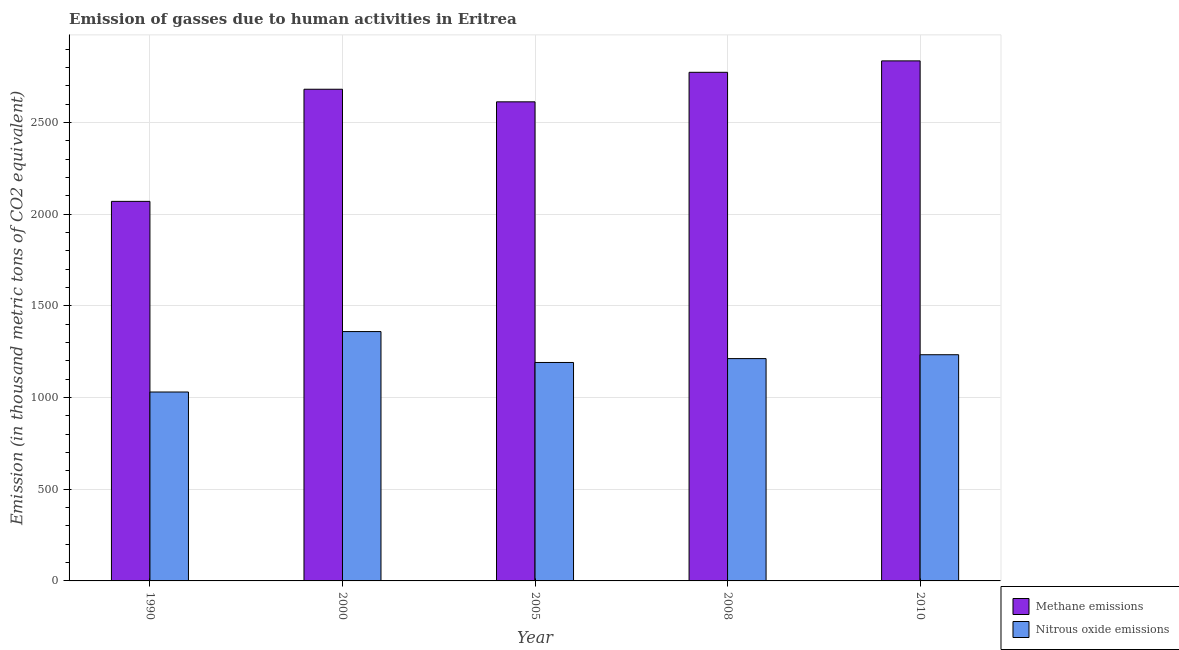How many different coloured bars are there?
Provide a short and direct response. 2. How many groups of bars are there?
Give a very brief answer. 5. How many bars are there on the 5th tick from the left?
Provide a short and direct response. 2. What is the label of the 2nd group of bars from the left?
Your response must be concise. 2000. In how many cases, is the number of bars for a given year not equal to the number of legend labels?
Give a very brief answer. 0. What is the amount of nitrous oxide emissions in 2005?
Ensure brevity in your answer.  1191.7. Across all years, what is the maximum amount of nitrous oxide emissions?
Provide a succinct answer. 1360.3. Across all years, what is the minimum amount of methane emissions?
Make the answer very short. 2070.6. In which year was the amount of methane emissions maximum?
Ensure brevity in your answer.  2010. In which year was the amount of nitrous oxide emissions minimum?
Your answer should be very brief. 1990. What is the total amount of methane emissions in the graph?
Give a very brief answer. 1.30e+04. What is the difference between the amount of methane emissions in 2005 and that in 2010?
Keep it short and to the point. -223.4. What is the difference between the amount of methane emissions in 2008 and the amount of nitrous oxide emissions in 2010?
Your answer should be compact. -62.3. What is the average amount of nitrous oxide emissions per year?
Offer a terse response. 1205.88. In the year 1990, what is the difference between the amount of nitrous oxide emissions and amount of methane emissions?
Provide a short and direct response. 0. In how many years, is the amount of nitrous oxide emissions greater than 1900 thousand metric tons?
Your answer should be compact. 0. What is the ratio of the amount of methane emissions in 1990 to that in 2000?
Give a very brief answer. 0.77. What is the difference between the highest and the second highest amount of methane emissions?
Make the answer very short. 62.3. What is the difference between the highest and the lowest amount of nitrous oxide emissions?
Keep it short and to the point. 329.7. What does the 1st bar from the left in 2000 represents?
Your answer should be very brief. Methane emissions. What does the 1st bar from the right in 2008 represents?
Your answer should be compact. Nitrous oxide emissions. Are all the bars in the graph horizontal?
Make the answer very short. No. What is the difference between two consecutive major ticks on the Y-axis?
Provide a succinct answer. 500. How are the legend labels stacked?
Offer a very short reply. Vertical. What is the title of the graph?
Your response must be concise. Emission of gasses due to human activities in Eritrea. Does "Rural Population" appear as one of the legend labels in the graph?
Ensure brevity in your answer.  No. What is the label or title of the Y-axis?
Provide a short and direct response. Emission (in thousand metric tons of CO2 equivalent). What is the Emission (in thousand metric tons of CO2 equivalent) in Methane emissions in 1990?
Your answer should be very brief. 2070.6. What is the Emission (in thousand metric tons of CO2 equivalent) of Nitrous oxide emissions in 1990?
Your response must be concise. 1030.6. What is the Emission (in thousand metric tons of CO2 equivalent) in Methane emissions in 2000?
Offer a very short reply. 2682.3. What is the Emission (in thousand metric tons of CO2 equivalent) of Nitrous oxide emissions in 2000?
Your response must be concise. 1360.3. What is the Emission (in thousand metric tons of CO2 equivalent) of Methane emissions in 2005?
Your response must be concise. 2613.6. What is the Emission (in thousand metric tons of CO2 equivalent) in Nitrous oxide emissions in 2005?
Offer a very short reply. 1191.7. What is the Emission (in thousand metric tons of CO2 equivalent) in Methane emissions in 2008?
Your answer should be compact. 2774.7. What is the Emission (in thousand metric tons of CO2 equivalent) of Nitrous oxide emissions in 2008?
Ensure brevity in your answer.  1212.8. What is the Emission (in thousand metric tons of CO2 equivalent) in Methane emissions in 2010?
Your answer should be very brief. 2837. What is the Emission (in thousand metric tons of CO2 equivalent) in Nitrous oxide emissions in 2010?
Provide a short and direct response. 1234. Across all years, what is the maximum Emission (in thousand metric tons of CO2 equivalent) in Methane emissions?
Your answer should be compact. 2837. Across all years, what is the maximum Emission (in thousand metric tons of CO2 equivalent) of Nitrous oxide emissions?
Give a very brief answer. 1360.3. Across all years, what is the minimum Emission (in thousand metric tons of CO2 equivalent) in Methane emissions?
Give a very brief answer. 2070.6. Across all years, what is the minimum Emission (in thousand metric tons of CO2 equivalent) in Nitrous oxide emissions?
Offer a very short reply. 1030.6. What is the total Emission (in thousand metric tons of CO2 equivalent) in Methane emissions in the graph?
Your answer should be very brief. 1.30e+04. What is the total Emission (in thousand metric tons of CO2 equivalent) of Nitrous oxide emissions in the graph?
Offer a terse response. 6029.4. What is the difference between the Emission (in thousand metric tons of CO2 equivalent) of Methane emissions in 1990 and that in 2000?
Your answer should be very brief. -611.7. What is the difference between the Emission (in thousand metric tons of CO2 equivalent) of Nitrous oxide emissions in 1990 and that in 2000?
Provide a succinct answer. -329.7. What is the difference between the Emission (in thousand metric tons of CO2 equivalent) in Methane emissions in 1990 and that in 2005?
Your answer should be compact. -543. What is the difference between the Emission (in thousand metric tons of CO2 equivalent) in Nitrous oxide emissions in 1990 and that in 2005?
Provide a short and direct response. -161.1. What is the difference between the Emission (in thousand metric tons of CO2 equivalent) of Methane emissions in 1990 and that in 2008?
Your response must be concise. -704.1. What is the difference between the Emission (in thousand metric tons of CO2 equivalent) in Nitrous oxide emissions in 1990 and that in 2008?
Make the answer very short. -182.2. What is the difference between the Emission (in thousand metric tons of CO2 equivalent) in Methane emissions in 1990 and that in 2010?
Keep it short and to the point. -766.4. What is the difference between the Emission (in thousand metric tons of CO2 equivalent) in Nitrous oxide emissions in 1990 and that in 2010?
Keep it short and to the point. -203.4. What is the difference between the Emission (in thousand metric tons of CO2 equivalent) in Methane emissions in 2000 and that in 2005?
Offer a very short reply. 68.7. What is the difference between the Emission (in thousand metric tons of CO2 equivalent) in Nitrous oxide emissions in 2000 and that in 2005?
Your response must be concise. 168.6. What is the difference between the Emission (in thousand metric tons of CO2 equivalent) in Methane emissions in 2000 and that in 2008?
Give a very brief answer. -92.4. What is the difference between the Emission (in thousand metric tons of CO2 equivalent) in Nitrous oxide emissions in 2000 and that in 2008?
Offer a terse response. 147.5. What is the difference between the Emission (in thousand metric tons of CO2 equivalent) of Methane emissions in 2000 and that in 2010?
Make the answer very short. -154.7. What is the difference between the Emission (in thousand metric tons of CO2 equivalent) of Nitrous oxide emissions in 2000 and that in 2010?
Your response must be concise. 126.3. What is the difference between the Emission (in thousand metric tons of CO2 equivalent) of Methane emissions in 2005 and that in 2008?
Ensure brevity in your answer.  -161.1. What is the difference between the Emission (in thousand metric tons of CO2 equivalent) of Nitrous oxide emissions in 2005 and that in 2008?
Give a very brief answer. -21.1. What is the difference between the Emission (in thousand metric tons of CO2 equivalent) in Methane emissions in 2005 and that in 2010?
Your response must be concise. -223.4. What is the difference between the Emission (in thousand metric tons of CO2 equivalent) of Nitrous oxide emissions in 2005 and that in 2010?
Keep it short and to the point. -42.3. What is the difference between the Emission (in thousand metric tons of CO2 equivalent) in Methane emissions in 2008 and that in 2010?
Give a very brief answer. -62.3. What is the difference between the Emission (in thousand metric tons of CO2 equivalent) of Nitrous oxide emissions in 2008 and that in 2010?
Ensure brevity in your answer.  -21.2. What is the difference between the Emission (in thousand metric tons of CO2 equivalent) of Methane emissions in 1990 and the Emission (in thousand metric tons of CO2 equivalent) of Nitrous oxide emissions in 2000?
Make the answer very short. 710.3. What is the difference between the Emission (in thousand metric tons of CO2 equivalent) of Methane emissions in 1990 and the Emission (in thousand metric tons of CO2 equivalent) of Nitrous oxide emissions in 2005?
Give a very brief answer. 878.9. What is the difference between the Emission (in thousand metric tons of CO2 equivalent) in Methane emissions in 1990 and the Emission (in thousand metric tons of CO2 equivalent) in Nitrous oxide emissions in 2008?
Ensure brevity in your answer.  857.8. What is the difference between the Emission (in thousand metric tons of CO2 equivalent) of Methane emissions in 1990 and the Emission (in thousand metric tons of CO2 equivalent) of Nitrous oxide emissions in 2010?
Your response must be concise. 836.6. What is the difference between the Emission (in thousand metric tons of CO2 equivalent) of Methane emissions in 2000 and the Emission (in thousand metric tons of CO2 equivalent) of Nitrous oxide emissions in 2005?
Your response must be concise. 1490.6. What is the difference between the Emission (in thousand metric tons of CO2 equivalent) in Methane emissions in 2000 and the Emission (in thousand metric tons of CO2 equivalent) in Nitrous oxide emissions in 2008?
Provide a short and direct response. 1469.5. What is the difference between the Emission (in thousand metric tons of CO2 equivalent) in Methane emissions in 2000 and the Emission (in thousand metric tons of CO2 equivalent) in Nitrous oxide emissions in 2010?
Give a very brief answer. 1448.3. What is the difference between the Emission (in thousand metric tons of CO2 equivalent) of Methane emissions in 2005 and the Emission (in thousand metric tons of CO2 equivalent) of Nitrous oxide emissions in 2008?
Your response must be concise. 1400.8. What is the difference between the Emission (in thousand metric tons of CO2 equivalent) of Methane emissions in 2005 and the Emission (in thousand metric tons of CO2 equivalent) of Nitrous oxide emissions in 2010?
Provide a short and direct response. 1379.6. What is the difference between the Emission (in thousand metric tons of CO2 equivalent) in Methane emissions in 2008 and the Emission (in thousand metric tons of CO2 equivalent) in Nitrous oxide emissions in 2010?
Your answer should be compact. 1540.7. What is the average Emission (in thousand metric tons of CO2 equivalent) in Methane emissions per year?
Your answer should be compact. 2595.64. What is the average Emission (in thousand metric tons of CO2 equivalent) of Nitrous oxide emissions per year?
Ensure brevity in your answer.  1205.88. In the year 1990, what is the difference between the Emission (in thousand metric tons of CO2 equivalent) of Methane emissions and Emission (in thousand metric tons of CO2 equivalent) of Nitrous oxide emissions?
Your answer should be very brief. 1040. In the year 2000, what is the difference between the Emission (in thousand metric tons of CO2 equivalent) in Methane emissions and Emission (in thousand metric tons of CO2 equivalent) in Nitrous oxide emissions?
Your answer should be compact. 1322. In the year 2005, what is the difference between the Emission (in thousand metric tons of CO2 equivalent) of Methane emissions and Emission (in thousand metric tons of CO2 equivalent) of Nitrous oxide emissions?
Provide a succinct answer. 1421.9. In the year 2008, what is the difference between the Emission (in thousand metric tons of CO2 equivalent) in Methane emissions and Emission (in thousand metric tons of CO2 equivalent) in Nitrous oxide emissions?
Give a very brief answer. 1561.9. In the year 2010, what is the difference between the Emission (in thousand metric tons of CO2 equivalent) of Methane emissions and Emission (in thousand metric tons of CO2 equivalent) of Nitrous oxide emissions?
Make the answer very short. 1603. What is the ratio of the Emission (in thousand metric tons of CO2 equivalent) of Methane emissions in 1990 to that in 2000?
Provide a succinct answer. 0.77. What is the ratio of the Emission (in thousand metric tons of CO2 equivalent) in Nitrous oxide emissions in 1990 to that in 2000?
Offer a very short reply. 0.76. What is the ratio of the Emission (in thousand metric tons of CO2 equivalent) in Methane emissions in 1990 to that in 2005?
Provide a succinct answer. 0.79. What is the ratio of the Emission (in thousand metric tons of CO2 equivalent) in Nitrous oxide emissions in 1990 to that in 2005?
Offer a very short reply. 0.86. What is the ratio of the Emission (in thousand metric tons of CO2 equivalent) in Methane emissions in 1990 to that in 2008?
Offer a very short reply. 0.75. What is the ratio of the Emission (in thousand metric tons of CO2 equivalent) of Nitrous oxide emissions in 1990 to that in 2008?
Give a very brief answer. 0.85. What is the ratio of the Emission (in thousand metric tons of CO2 equivalent) of Methane emissions in 1990 to that in 2010?
Offer a very short reply. 0.73. What is the ratio of the Emission (in thousand metric tons of CO2 equivalent) in Nitrous oxide emissions in 1990 to that in 2010?
Offer a very short reply. 0.84. What is the ratio of the Emission (in thousand metric tons of CO2 equivalent) in Methane emissions in 2000 to that in 2005?
Ensure brevity in your answer.  1.03. What is the ratio of the Emission (in thousand metric tons of CO2 equivalent) in Nitrous oxide emissions in 2000 to that in 2005?
Offer a very short reply. 1.14. What is the ratio of the Emission (in thousand metric tons of CO2 equivalent) in Methane emissions in 2000 to that in 2008?
Keep it short and to the point. 0.97. What is the ratio of the Emission (in thousand metric tons of CO2 equivalent) in Nitrous oxide emissions in 2000 to that in 2008?
Offer a terse response. 1.12. What is the ratio of the Emission (in thousand metric tons of CO2 equivalent) of Methane emissions in 2000 to that in 2010?
Ensure brevity in your answer.  0.95. What is the ratio of the Emission (in thousand metric tons of CO2 equivalent) in Nitrous oxide emissions in 2000 to that in 2010?
Provide a short and direct response. 1.1. What is the ratio of the Emission (in thousand metric tons of CO2 equivalent) in Methane emissions in 2005 to that in 2008?
Provide a short and direct response. 0.94. What is the ratio of the Emission (in thousand metric tons of CO2 equivalent) of Nitrous oxide emissions in 2005 to that in 2008?
Your response must be concise. 0.98. What is the ratio of the Emission (in thousand metric tons of CO2 equivalent) of Methane emissions in 2005 to that in 2010?
Your answer should be compact. 0.92. What is the ratio of the Emission (in thousand metric tons of CO2 equivalent) of Nitrous oxide emissions in 2005 to that in 2010?
Your answer should be very brief. 0.97. What is the ratio of the Emission (in thousand metric tons of CO2 equivalent) of Methane emissions in 2008 to that in 2010?
Ensure brevity in your answer.  0.98. What is the ratio of the Emission (in thousand metric tons of CO2 equivalent) in Nitrous oxide emissions in 2008 to that in 2010?
Offer a terse response. 0.98. What is the difference between the highest and the second highest Emission (in thousand metric tons of CO2 equivalent) in Methane emissions?
Provide a short and direct response. 62.3. What is the difference between the highest and the second highest Emission (in thousand metric tons of CO2 equivalent) in Nitrous oxide emissions?
Offer a very short reply. 126.3. What is the difference between the highest and the lowest Emission (in thousand metric tons of CO2 equivalent) in Methane emissions?
Ensure brevity in your answer.  766.4. What is the difference between the highest and the lowest Emission (in thousand metric tons of CO2 equivalent) of Nitrous oxide emissions?
Your response must be concise. 329.7. 